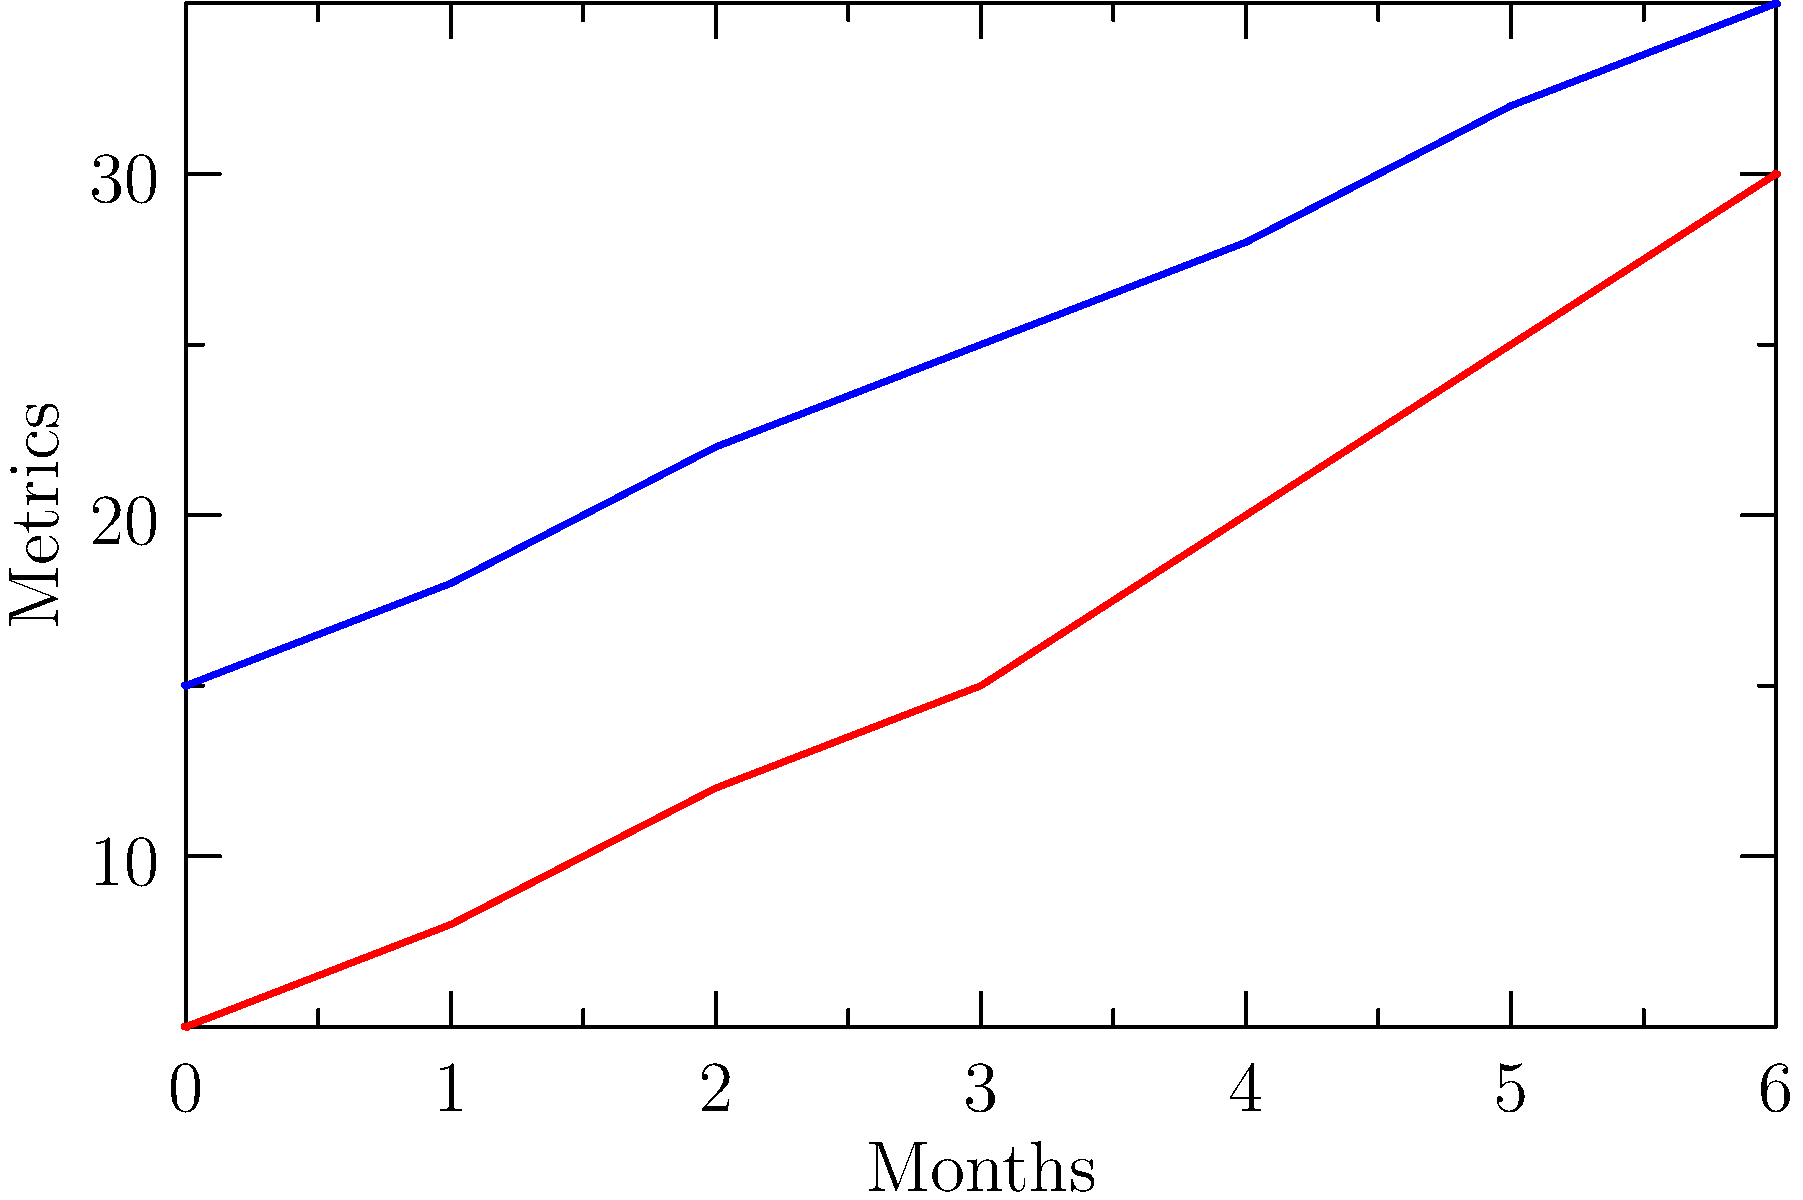As the CEO of your tech startup, you're analyzing Instagram engagement trends. The graph shows your company's Instagram engagement rate and posting frequency over the past 7 months. If the current trends continue, what would be the expected engagement rate when the number of posts per week reaches 40, assuming a linear relationship? Round your answer to the nearest whole percentage. To solve this problem, we need to follow these steps:

1. Identify the relationship between posts per week and engagement rate:
   - At 5 posts/week, engagement rate is 15%
   - At 30 posts/week, engagement rate is 35%

2. Calculate the rate of change in engagement rate with respect to posts:
   $\frac{\Delta \text{Engagement}}{\Delta \text{Posts}} = \frac{35\% - 15\%}{30 - 5} = \frac{20\%}{25} = 0.8\%$ per post

3. Determine how many more posts are needed to reach 40 posts/week:
   $40 - 30 = 10$ additional posts

4. Calculate the expected increase in engagement rate:
   $0.8\% \times 10 = 8\%$ increase

5. Add this increase to the current engagement rate:
   $35\% + 8\% = 43\%$

Therefore, the expected engagement rate when reaching 40 posts per week is 43%.
Answer: 43% 